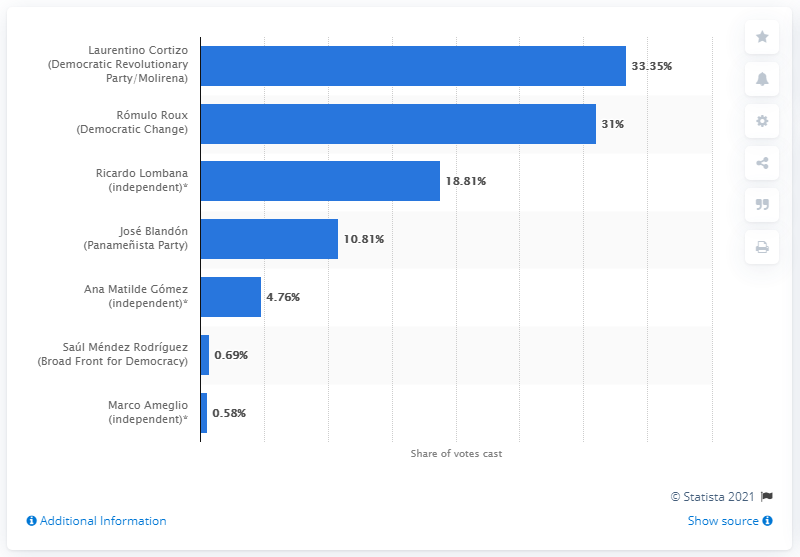Indicate a few pertinent items in this graphic. According to voting intention polls, the predicted percentage of votes received by Cortizo was 33.35%. Laurentino Cortizo received 33.35% of the votes in the election. 